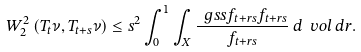<formula> <loc_0><loc_0><loc_500><loc_500>W _ { 2 } ^ { 2 } \left ( T _ { t } \nu , T _ { t + s } \nu \right ) \leq { s ^ { 2 } } \int _ { 0 } ^ { 1 } \int _ { X } \frac { \ g s s { f _ { t + r s } } { f _ { t + r s } } } { f _ { t + r s } } \, d \ v o l \, d r .</formula> 